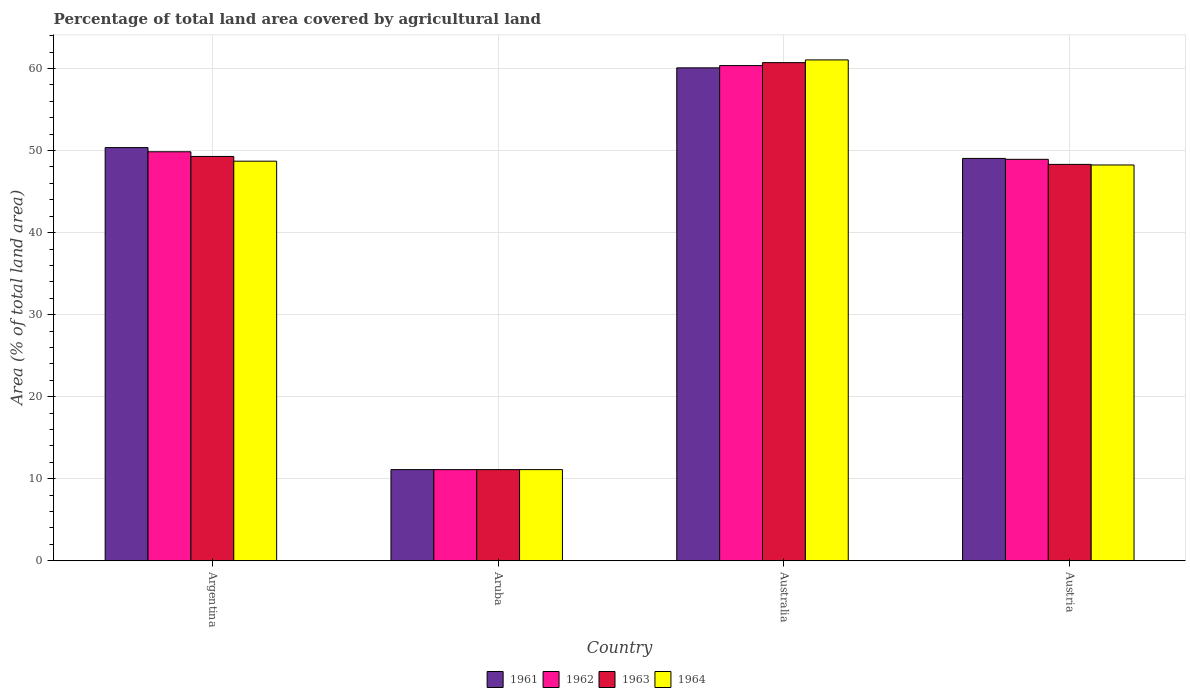How many bars are there on the 1st tick from the right?
Keep it short and to the point. 4. In how many cases, is the number of bars for a given country not equal to the number of legend labels?
Offer a terse response. 0. What is the percentage of agricultural land in 1963 in Australia?
Provide a succinct answer. 60.72. Across all countries, what is the maximum percentage of agricultural land in 1961?
Offer a very short reply. 60.08. Across all countries, what is the minimum percentage of agricultural land in 1964?
Provide a short and direct response. 11.11. In which country was the percentage of agricultural land in 1964 maximum?
Offer a very short reply. Australia. In which country was the percentage of agricultural land in 1963 minimum?
Provide a succinct answer. Aruba. What is the total percentage of agricultural land in 1964 in the graph?
Provide a succinct answer. 169.11. What is the difference between the percentage of agricultural land in 1963 in Argentina and that in Aruba?
Provide a succinct answer. 38.17. What is the difference between the percentage of agricultural land in 1961 in Argentina and the percentage of agricultural land in 1962 in Austria?
Your answer should be very brief. 1.43. What is the average percentage of agricultural land in 1962 per country?
Provide a succinct answer. 42.56. What is the difference between the percentage of agricultural land of/in 1961 and percentage of agricultural land of/in 1962 in Austria?
Your response must be concise. 0.11. In how many countries, is the percentage of agricultural land in 1963 greater than 56 %?
Provide a succinct answer. 1. What is the ratio of the percentage of agricultural land in 1964 in Aruba to that in Australia?
Provide a succinct answer. 0.18. Is the percentage of agricultural land in 1963 in Argentina less than that in Aruba?
Offer a terse response. No. Is the difference between the percentage of agricultural land in 1961 in Argentina and Austria greater than the difference between the percentage of agricultural land in 1962 in Argentina and Austria?
Your answer should be very brief. Yes. What is the difference between the highest and the second highest percentage of agricultural land in 1962?
Your response must be concise. -0.92. What is the difference between the highest and the lowest percentage of agricultural land in 1961?
Offer a terse response. 48.97. What does the 3rd bar from the left in Aruba represents?
Your response must be concise. 1963. Is it the case that in every country, the sum of the percentage of agricultural land in 1963 and percentage of agricultural land in 1961 is greater than the percentage of agricultural land in 1964?
Provide a short and direct response. Yes. How many bars are there?
Give a very brief answer. 16. How many countries are there in the graph?
Give a very brief answer. 4. What is the difference between two consecutive major ticks on the Y-axis?
Keep it short and to the point. 10. Does the graph contain any zero values?
Your response must be concise. No. Where does the legend appear in the graph?
Your response must be concise. Bottom center. How are the legend labels stacked?
Your answer should be compact. Horizontal. What is the title of the graph?
Your answer should be very brief. Percentage of total land area covered by agricultural land. Does "1969" appear as one of the legend labels in the graph?
Offer a very short reply. No. What is the label or title of the Y-axis?
Your response must be concise. Area (% of total land area). What is the Area (% of total land area) of 1961 in Argentina?
Provide a succinct answer. 50.36. What is the Area (% of total land area) of 1962 in Argentina?
Your answer should be compact. 49.85. What is the Area (% of total land area) of 1963 in Argentina?
Provide a succinct answer. 49.28. What is the Area (% of total land area) in 1964 in Argentina?
Ensure brevity in your answer.  48.71. What is the Area (% of total land area) in 1961 in Aruba?
Make the answer very short. 11.11. What is the Area (% of total land area) of 1962 in Aruba?
Your response must be concise. 11.11. What is the Area (% of total land area) in 1963 in Aruba?
Your answer should be very brief. 11.11. What is the Area (% of total land area) in 1964 in Aruba?
Provide a succinct answer. 11.11. What is the Area (% of total land area) in 1961 in Australia?
Provide a short and direct response. 60.08. What is the Area (% of total land area) in 1962 in Australia?
Provide a succinct answer. 60.36. What is the Area (% of total land area) in 1963 in Australia?
Make the answer very short. 60.72. What is the Area (% of total land area) of 1964 in Australia?
Offer a terse response. 61.05. What is the Area (% of total land area) of 1961 in Austria?
Your answer should be very brief. 49.04. What is the Area (% of total land area) in 1962 in Austria?
Offer a very short reply. 48.93. What is the Area (% of total land area) of 1963 in Austria?
Provide a short and direct response. 48.32. What is the Area (% of total land area) of 1964 in Austria?
Make the answer very short. 48.24. Across all countries, what is the maximum Area (% of total land area) in 1961?
Ensure brevity in your answer.  60.08. Across all countries, what is the maximum Area (% of total land area) of 1962?
Offer a terse response. 60.36. Across all countries, what is the maximum Area (% of total land area) of 1963?
Offer a terse response. 60.72. Across all countries, what is the maximum Area (% of total land area) in 1964?
Provide a short and direct response. 61.05. Across all countries, what is the minimum Area (% of total land area) of 1961?
Offer a very short reply. 11.11. Across all countries, what is the minimum Area (% of total land area) of 1962?
Offer a terse response. 11.11. Across all countries, what is the minimum Area (% of total land area) in 1963?
Keep it short and to the point. 11.11. Across all countries, what is the minimum Area (% of total land area) in 1964?
Keep it short and to the point. 11.11. What is the total Area (% of total land area) of 1961 in the graph?
Your answer should be compact. 170.6. What is the total Area (% of total land area) in 1962 in the graph?
Keep it short and to the point. 170.26. What is the total Area (% of total land area) of 1963 in the graph?
Offer a very short reply. 169.43. What is the total Area (% of total land area) in 1964 in the graph?
Keep it short and to the point. 169.11. What is the difference between the Area (% of total land area) of 1961 in Argentina and that in Aruba?
Keep it short and to the point. 39.25. What is the difference between the Area (% of total land area) in 1962 in Argentina and that in Aruba?
Your answer should be compact. 38.74. What is the difference between the Area (% of total land area) of 1963 in Argentina and that in Aruba?
Give a very brief answer. 38.17. What is the difference between the Area (% of total land area) in 1964 in Argentina and that in Aruba?
Provide a short and direct response. 37.6. What is the difference between the Area (% of total land area) of 1961 in Argentina and that in Australia?
Give a very brief answer. -9.72. What is the difference between the Area (% of total land area) in 1962 in Argentina and that in Australia?
Your answer should be very brief. -10.5. What is the difference between the Area (% of total land area) of 1963 in Argentina and that in Australia?
Your response must be concise. -11.44. What is the difference between the Area (% of total land area) of 1964 in Argentina and that in Australia?
Your answer should be compact. -12.34. What is the difference between the Area (% of total land area) of 1961 in Argentina and that in Austria?
Offer a very short reply. 1.32. What is the difference between the Area (% of total land area) of 1962 in Argentina and that in Austria?
Your answer should be compact. 0.92. What is the difference between the Area (% of total land area) in 1963 in Argentina and that in Austria?
Your response must be concise. 0.97. What is the difference between the Area (% of total land area) of 1964 in Argentina and that in Austria?
Offer a very short reply. 0.46. What is the difference between the Area (% of total land area) of 1961 in Aruba and that in Australia?
Make the answer very short. -48.97. What is the difference between the Area (% of total land area) in 1962 in Aruba and that in Australia?
Keep it short and to the point. -49.25. What is the difference between the Area (% of total land area) of 1963 in Aruba and that in Australia?
Provide a succinct answer. -49.61. What is the difference between the Area (% of total land area) of 1964 in Aruba and that in Australia?
Your response must be concise. -49.94. What is the difference between the Area (% of total land area) in 1961 in Aruba and that in Austria?
Your answer should be very brief. -37.93. What is the difference between the Area (% of total land area) of 1962 in Aruba and that in Austria?
Your answer should be compact. -37.82. What is the difference between the Area (% of total land area) in 1963 in Aruba and that in Austria?
Provide a short and direct response. -37.21. What is the difference between the Area (% of total land area) of 1964 in Aruba and that in Austria?
Your response must be concise. -37.13. What is the difference between the Area (% of total land area) in 1961 in Australia and that in Austria?
Offer a very short reply. 11.04. What is the difference between the Area (% of total land area) of 1962 in Australia and that in Austria?
Your answer should be very brief. 11.42. What is the difference between the Area (% of total land area) of 1963 in Australia and that in Austria?
Provide a succinct answer. 12.4. What is the difference between the Area (% of total land area) in 1964 in Australia and that in Austria?
Make the answer very short. 12.81. What is the difference between the Area (% of total land area) in 1961 in Argentina and the Area (% of total land area) in 1962 in Aruba?
Give a very brief answer. 39.25. What is the difference between the Area (% of total land area) of 1961 in Argentina and the Area (% of total land area) of 1963 in Aruba?
Give a very brief answer. 39.25. What is the difference between the Area (% of total land area) in 1961 in Argentina and the Area (% of total land area) in 1964 in Aruba?
Keep it short and to the point. 39.25. What is the difference between the Area (% of total land area) of 1962 in Argentina and the Area (% of total land area) of 1963 in Aruba?
Make the answer very short. 38.74. What is the difference between the Area (% of total land area) of 1962 in Argentina and the Area (% of total land area) of 1964 in Aruba?
Offer a very short reply. 38.74. What is the difference between the Area (% of total land area) of 1963 in Argentina and the Area (% of total land area) of 1964 in Aruba?
Your response must be concise. 38.17. What is the difference between the Area (% of total land area) of 1961 in Argentina and the Area (% of total land area) of 1962 in Australia?
Provide a short and direct response. -9.99. What is the difference between the Area (% of total land area) of 1961 in Argentina and the Area (% of total land area) of 1963 in Australia?
Your answer should be very brief. -10.36. What is the difference between the Area (% of total land area) of 1961 in Argentina and the Area (% of total land area) of 1964 in Australia?
Give a very brief answer. -10.69. What is the difference between the Area (% of total land area) of 1962 in Argentina and the Area (% of total land area) of 1963 in Australia?
Provide a succinct answer. -10.87. What is the difference between the Area (% of total land area) of 1962 in Argentina and the Area (% of total land area) of 1964 in Australia?
Your answer should be compact. -11.2. What is the difference between the Area (% of total land area) of 1963 in Argentina and the Area (% of total land area) of 1964 in Australia?
Make the answer very short. -11.77. What is the difference between the Area (% of total land area) of 1961 in Argentina and the Area (% of total land area) of 1962 in Austria?
Your answer should be compact. 1.43. What is the difference between the Area (% of total land area) of 1961 in Argentina and the Area (% of total land area) of 1963 in Austria?
Your response must be concise. 2.05. What is the difference between the Area (% of total land area) in 1961 in Argentina and the Area (% of total land area) in 1964 in Austria?
Your response must be concise. 2.12. What is the difference between the Area (% of total land area) of 1962 in Argentina and the Area (% of total land area) of 1963 in Austria?
Make the answer very short. 1.54. What is the difference between the Area (% of total land area) in 1962 in Argentina and the Area (% of total land area) in 1964 in Austria?
Provide a short and direct response. 1.61. What is the difference between the Area (% of total land area) in 1963 in Argentina and the Area (% of total land area) in 1964 in Austria?
Offer a very short reply. 1.04. What is the difference between the Area (% of total land area) in 1961 in Aruba and the Area (% of total land area) in 1962 in Australia?
Give a very brief answer. -49.25. What is the difference between the Area (% of total land area) in 1961 in Aruba and the Area (% of total land area) in 1963 in Australia?
Make the answer very short. -49.61. What is the difference between the Area (% of total land area) of 1961 in Aruba and the Area (% of total land area) of 1964 in Australia?
Provide a short and direct response. -49.94. What is the difference between the Area (% of total land area) in 1962 in Aruba and the Area (% of total land area) in 1963 in Australia?
Give a very brief answer. -49.61. What is the difference between the Area (% of total land area) in 1962 in Aruba and the Area (% of total land area) in 1964 in Australia?
Offer a very short reply. -49.94. What is the difference between the Area (% of total land area) in 1963 in Aruba and the Area (% of total land area) in 1964 in Australia?
Provide a short and direct response. -49.94. What is the difference between the Area (% of total land area) of 1961 in Aruba and the Area (% of total land area) of 1962 in Austria?
Keep it short and to the point. -37.82. What is the difference between the Area (% of total land area) in 1961 in Aruba and the Area (% of total land area) in 1963 in Austria?
Ensure brevity in your answer.  -37.21. What is the difference between the Area (% of total land area) of 1961 in Aruba and the Area (% of total land area) of 1964 in Austria?
Provide a succinct answer. -37.13. What is the difference between the Area (% of total land area) of 1962 in Aruba and the Area (% of total land area) of 1963 in Austria?
Give a very brief answer. -37.21. What is the difference between the Area (% of total land area) in 1962 in Aruba and the Area (% of total land area) in 1964 in Austria?
Provide a succinct answer. -37.13. What is the difference between the Area (% of total land area) in 1963 in Aruba and the Area (% of total land area) in 1964 in Austria?
Provide a short and direct response. -37.13. What is the difference between the Area (% of total land area) of 1961 in Australia and the Area (% of total land area) of 1962 in Austria?
Give a very brief answer. 11.15. What is the difference between the Area (% of total land area) of 1961 in Australia and the Area (% of total land area) of 1963 in Austria?
Ensure brevity in your answer.  11.77. What is the difference between the Area (% of total land area) of 1961 in Australia and the Area (% of total land area) of 1964 in Austria?
Provide a short and direct response. 11.84. What is the difference between the Area (% of total land area) of 1962 in Australia and the Area (% of total land area) of 1963 in Austria?
Provide a succinct answer. 12.04. What is the difference between the Area (% of total land area) of 1962 in Australia and the Area (% of total land area) of 1964 in Austria?
Your answer should be compact. 12.11. What is the difference between the Area (% of total land area) in 1963 in Australia and the Area (% of total land area) in 1964 in Austria?
Make the answer very short. 12.48. What is the average Area (% of total land area) in 1961 per country?
Ensure brevity in your answer.  42.65. What is the average Area (% of total land area) in 1962 per country?
Keep it short and to the point. 42.56. What is the average Area (% of total land area) of 1963 per country?
Provide a succinct answer. 42.36. What is the average Area (% of total land area) of 1964 per country?
Offer a terse response. 42.28. What is the difference between the Area (% of total land area) in 1961 and Area (% of total land area) in 1962 in Argentina?
Offer a terse response. 0.51. What is the difference between the Area (% of total land area) in 1961 and Area (% of total land area) in 1963 in Argentina?
Give a very brief answer. 1.08. What is the difference between the Area (% of total land area) of 1961 and Area (% of total land area) of 1964 in Argentina?
Your response must be concise. 1.66. What is the difference between the Area (% of total land area) in 1962 and Area (% of total land area) in 1963 in Argentina?
Your answer should be compact. 0.57. What is the difference between the Area (% of total land area) of 1962 and Area (% of total land area) of 1964 in Argentina?
Provide a short and direct response. 1.15. What is the difference between the Area (% of total land area) in 1963 and Area (% of total land area) in 1964 in Argentina?
Give a very brief answer. 0.58. What is the difference between the Area (% of total land area) of 1961 and Area (% of total land area) of 1962 in Aruba?
Provide a succinct answer. 0. What is the difference between the Area (% of total land area) in 1961 and Area (% of total land area) in 1963 in Aruba?
Offer a very short reply. 0. What is the difference between the Area (% of total land area) of 1961 and Area (% of total land area) of 1964 in Aruba?
Offer a terse response. 0. What is the difference between the Area (% of total land area) in 1962 and Area (% of total land area) in 1964 in Aruba?
Offer a very short reply. 0. What is the difference between the Area (% of total land area) in 1963 and Area (% of total land area) in 1964 in Aruba?
Ensure brevity in your answer.  0. What is the difference between the Area (% of total land area) of 1961 and Area (% of total land area) of 1962 in Australia?
Offer a very short reply. -0.27. What is the difference between the Area (% of total land area) of 1961 and Area (% of total land area) of 1963 in Australia?
Offer a very short reply. -0.64. What is the difference between the Area (% of total land area) in 1961 and Area (% of total land area) in 1964 in Australia?
Your answer should be compact. -0.97. What is the difference between the Area (% of total land area) of 1962 and Area (% of total land area) of 1963 in Australia?
Make the answer very short. -0.36. What is the difference between the Area (% of total land area) in 1962 and Area (% of total land area) in 1964 in Australia?
Give a very brief answer. -0.69. What is the difference between the Area (% of total land area) of 1963 and Area (% of total land area) of 1964 in Australia?
Ensure brevity in your answer.  -0.33. What is the difference between the Area (% of total land area) of 1961 and Area (% of total land area) of 1962 in Austria?
Your answer should be compact. 0.11. What is the difference between the Area (% of total land area) of 1961 and Area (% of total land area) of 1963 in Austria?
Provide a short and direct response. 0.73. What is the difference between the Area (% of total land area) in 1961 and Area (% of total land area) in 1964 in Austria?
Make the answer very short. 0.8. What is the difference between the Area (% of total land area) of 1962 and Area (% of total land area) of 1963 in Austria?
Provide a succinct answer. 0.62. What is the difference between the Area (% of total land area) in 1962 and Area (% of total land area) in 1964 in Austria?
Your answer should be very brief. 0.69. What is the difference between the Area (% of total land area) in 1963 and Area (% of total land area) in 1964 in Austria?
Offer a very short reply. 0.07. What is the ratio of the Area (% of total land area) of 1961 in Argentina to that in Aruba?
Offer a terse response. 4.53. What is the ratio of the Area (% of total land area) in 1962 in Argentina to that in Aruba?
Offer a very short reply. 4.49. What is the ratio of the Area (% of total land area) in 1963 in Argentina to that in Aruba?
Provide a short and direct response. 4.44. What is the ratio of the Area (% of total land area) in 1964 in Argentina to that in Aruba?
Ensure brevity in your answer.  4.38. What is the ratio of the Area (% of total land area) in 1961 in Argentina to that in Australia?
Provide a succinct answer. 0.84. What is the ratio of the Area (% of total land area) in 1962 in Argentina to that in Australia?
Your response must be concise. 0.83. What is the ratio of the Area (% of total land area) of 1963 in Argentina to that in Australia?
Give a very brief answer. 0.81. What is the ratio of the Area (% of total land area) in 1964 in Argentina to that in Australia?
Make the answer very short. 0.8. What is the ratio of the Area (% of total land area) in 1961 in Argentina to that in Austria?
Offer a terse response. 1.03. What is the ratio of the Area (% of total land area) in 1962 in Argentina to that in Austria?
Your response must be concise. 1.02. What is the ratio of the Area (% of total land area) of 1963 in Argentina to that in Austria?
Provide a short and direct response. 1.02. What is the ratio of the Area (% of total land area) in 1964 in Argentina to that in Austria?
Provide a short and direct response. 1.01. What is the ratio of the Area (% of total land area) in 1961 in Aruba to that in Australia?
Give a very brief answer. 0.18. What is the ratio of the Area (% of total land area) in 1962 in Aruba to that in Australia?
Ensure brevity in your answer.  0.18. What is the ratio of the Area (% of total land area) in 1963 in Aruba to that in Australia?
Keep it short and to the point. 0.18. What is the ratio of the Area (% of total land area) in 1964 in Aruba to that in Australia?
Ensure brevity in your answer.  0.18. What is the ratio of the Area (% of total land area) in 1961 in Aruba to that in Austria?
Your response must be concise. 0.23. What is the ratio of the Area (% of total land area) of 1962 in Aruba to that in Austria?
Your answer should be compact. 0.23. What is the ratio of the Area (% of total land area) in 1963 in Aruba to that in Austria?
Provide a short and direct response. 0.23. What is the ratio of the Area (% of total land area) in 1964 in Aruba to that in Austria?
Provide a succinct answer. 0.23. What is the ratio of the Area (% of total land area) in 1961 in Australia to that in Austria?
Provide a succinct answer. 1.23. What is the ratio of the Area (% of total land area) of 1962 in Australia to that in Austria?
Keep it short and to the point. 1.23. What is the ratio of the Area (% of total land area) of 1963 in Australia to that in Austria?
Offer a very short reply. 1.26. What is the ratio of the Area (% of total land area) in 1964 in Australia to that in Austria?
Make the answer very short. 1.27. What is the difference between the highest and the second highest Area (% of total land area) in 1961?
Keep it short and to the point. 9.72. What is the difference between the highest and the second highest Area (% of total land area) in 1962?
Your answer should be compact. 10.5. What is the difference between the highest and the second highest Area (% of total land area) in 1963?
Ensure brevity in your answer.  11.44. What is the difference between the highest and the second highest Area (% of total land area) in 1964?
Your response must be concise. 12.34. What is the difference between the highest and the lowest Area (% of total land area) in 1961?
Provide a succinct answer. 48.97. What is the difference between the highest and the lowest Area (% of total land area) of 1962?
Your answer should be very brief. 49.25. What is the difference between the highest and the lowest Area (% of total land area) in 1963?
Your answer should be very brief. 49.61. What is the difference between the highest and the lowest Area (% of total land area) of 1964?
Your response must be concise. 49.94. 